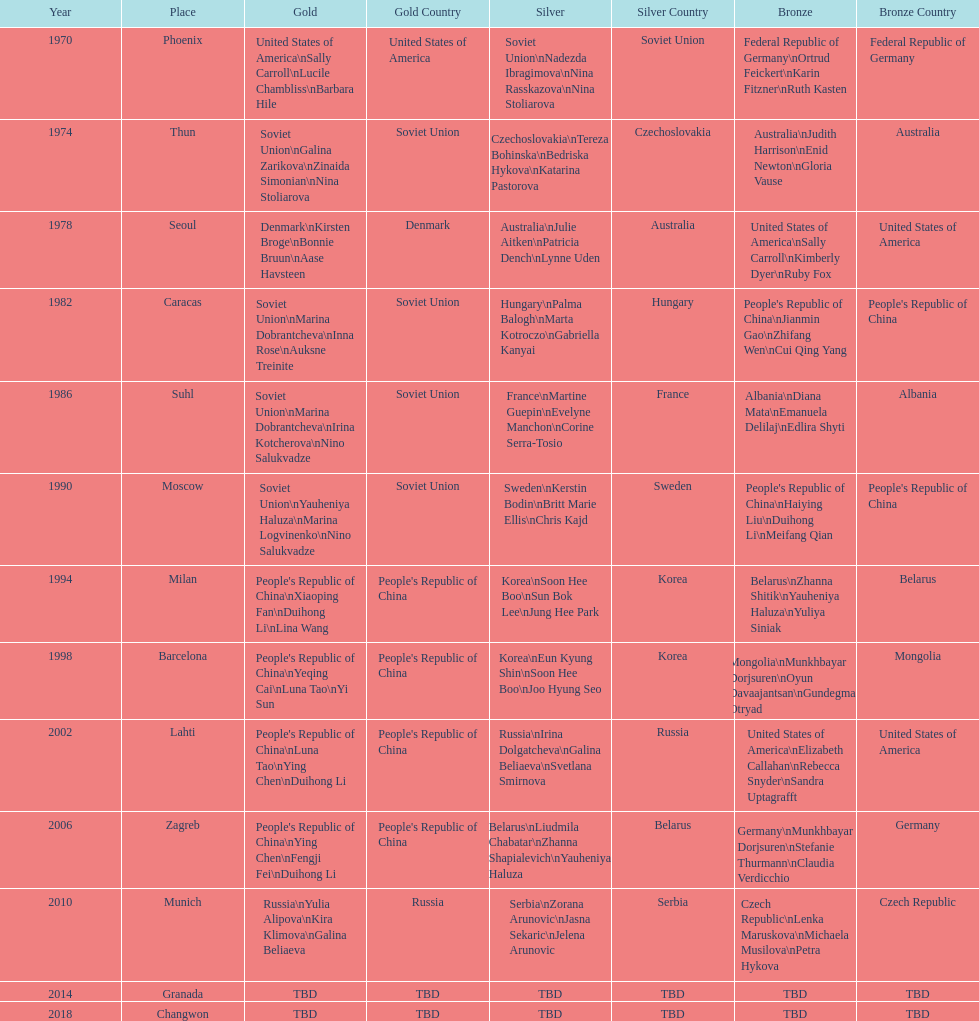What is the number of total bronze medals that germany has won? 1. Can you give me this table as a dict? {'header': ['Year', 'Place', 'Gold', 'Gold Country', 'Silver', 'Silver Country', 'Bronze', 'Bronze Country'], 'rows': [['1970', 'Phoenix', 'United States of America\\nSally Carroll\\nLucile Chambliss\\nBarbara Hile', 'United States of America', 'Soviet Union\\nNadezda Ibragimova\\nNina Rasskazova\\nNina Stoliarova', 'Soviet Union', 'Federal Republic of Germany\\nOrtrud Feickert\\nKarin Fitzner\\nRuth Kasten', 'Federal Republic of Germany'], ['1974', 'Thun', 'Soviet Union\\nGalina Zarikova\\nZinaida Simonian\\nNina Stoliarova', 'Soviet Union', 'Czechoslovakia\\nTereza Bohinska\\nBedriska Hykova\\nKatarina Pastorova', 'Czechoslovakia', 'Australia\\nJudith Harrison\\nEnid Newton\\nGloria Vause', 'Australia'], ['1978', 'Seoul', 'Denmark\\nKirsten Broge\\nBonnie Bruun\\nAase Havsteen', 'Denmark', 'Australia\\nJulie Aitken\\nPatricia Dench\\nLynne Uden', 'Australia', 'United States of America\\nSally Carroll\\nKimberly Dyer\\nRuby Fox', 'United States of America'], ['1982', 'Caracas', 'Soviet Union\\nMarina Dobrantcheva\\nInna Rose\\nAuksne Treinite', 'Soviet Union', 'Hungary\\nPalma Balogh\\nMarta Kotroczo\\nGabriella Kanyai', 'Hungary', "People's Republic of China\\nJianmin Gao\\nZhifang Wen\\nCui Qing Yang", "People's Republic of China"], ['1986', 'Suhl', 'Soviet Union\\nMarina Dobrantcheva\\nIrina Kotcherova\\nNino Salukvadze', 'Soviet Union', 'France\\nMartine Guepin\\nEvelyne Manchon\\nCorine Serra-Tosio', 'France', 'Albania\\nDiana Mata\\nEmanuela Delilaj\\nEdlira Shyti', 'Albania'], ['1990', 'Moscow', 'Soviet Union\\nYauheniya Haluza\\nMarina Logvinenko\\nNino Salukvadze', 'Soviet Union', 'Sweden\\nKerstin Bodin\\nBritt Marie Ellis\\nChris Kajd', 'Sweden', "People's Republic of China\\nHaiying Liu\\nDuihong Li\\nMeifang Qian", "People's Republic of China"], ['1994', 'Milan', "People's Republic of China\\nXiaoping Fan\\nDuihong Li\\nLina Wang", "People's Republic of China", 'Korea\\nSoon Hee Boo\\nSun Bok Lee\\nJung Hee Park', 'Korea', 'Belarus\\nZhanna Shitik\\nYauheniya Haluza\\nYuliya Siniak', 'Belarus'], ['1998', 'Barcelona', "People's Republic of China\\nYeqing Cai\\nLuna Tao\\nYi Sun", "People's Republic of China", 'Korea\\nEun Kyung Shin\\nSoon Hee Boo\\nJoo Hyung Seo', 'Korea', 'Mongolia\\nMunkhbayar Dorjsuren\\nOyun Davaajantsan\\nGundegmaa Otryad', 'Mongolia'], ['2002', 'Lahti', "People's Republic of China\\nLuna Tao\\nYing Chen\\nDuihong Li", "People's Republic of China", 'Russia\\nIrina Dolgatcheva\\nGalina Beliaeva\\nSvetlana Smirnova', 'Russia', 'United States of America\\nElizabeth Callahan\\nRebecca Snyder\\nSandra Uptagrafft', 'United States of America'], ['2006', 'Zagreb', "People's Republic of China\\nYing Chen\\nFengji Fei\\nDuihong Li", "People's Republic of China", 'Belarus\\nLiudmila Chabatar\\nZhanna Shapialevich\\nYauheniya Haluza', 'Belarus', 'Germany\\nMunkhbayar Dorjsuren\\nStefanie Thurmann\\nClaudia Verdicchio', 'Germany'], ['2010', 'Munich', 'Russia\\nYulia Alipova\\nKira Klimova\\nGalina Beliaeva', 'Russia', 'Serbia\\nZorana Arunovic\\nJasna Sekaric\\nJelena Arunovic', 'Serbia', 'Czech Republic\\nLenka Maruskova\\nMichaela Musilova\\nPetra Hykova', 'Czech Republic'], ['2014', 'Granada', 'TBD', 'TBD', 'TBD', 'TBD', 'TBD', 'TBD'], ['2018', 'Changwon', 'TBD', 'TBD', 'TBD', 'TBD', 'TBD', 'TBD']]} 